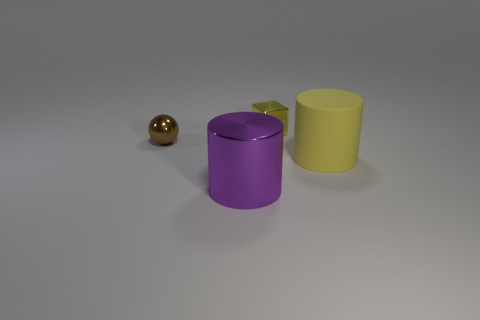Add 2 tiny gray metallic blocks. How many objects exist? 6 Subtract all blocks. How many objects are left? 3 Subtract all large purple cylinders. Subtract all small green rubber blocks. How many objects are left? 3 Add 1 big purple metal cylinders. How many big purple metal cylinders are left? 2 Add 1 red matte spheres. How many red matte spheres exist? 1 Subtract 0 blue spheres. How many objects are left? 4 